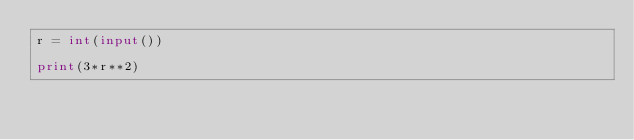<code> <loc_0><loc_0><loc_500><loc_500><_Python_>r = int(input())

print(3*r**2)</code> 